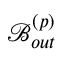<formula> <loc_0><loc_0><loc_500><loc_500>\mathcal { B } _ { o u t } ^ { \left ( p \right ) }</formula> 